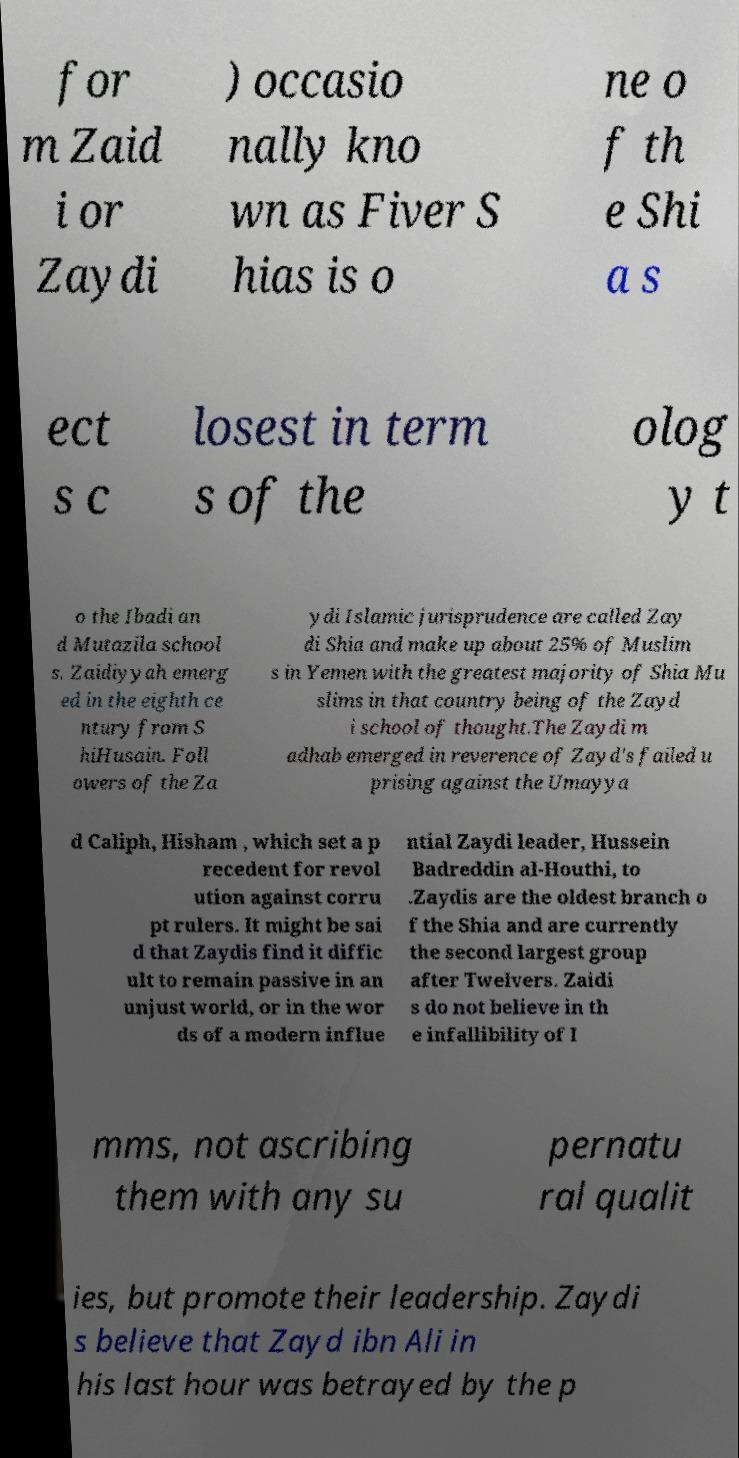Please identify and transcribe the text found in this image. for m Zaid i or Zaydi ) occasio nally kno wn as Fiver S hias is o ne o f th e Shi a s ect s c losest in term s of the olog y t o the Ibadi an d Mutazila school s. Zaidiyyah emerg ed in the eighth ce ntury from S hiHusain. Foll owers of the Za ydi Islamic jurisprudence are called Zay di Shia and make up about 25% of Muslim s in Yemen with the greatest majority of Shia Mu slims in that country being of the Zayd i school of thought.The Zaydi m adhab emerged in reverence of Zayd's failed u prising against the Umayya d Caliph, Hisham , which set a p recedent for revol ution against corru pt rulers. It might be sai d that Zaydis find it diffic ult to remain passive in an unjust world, or in the wor ds of a modern influe ntial Zaydi leader, Hussein Badreddin al-Houthi, to .Zaydis are the oldest branch o f the Shia and are currently the second largest group after Twelvers. Zaidi s do not believe in th e infallibility of I mms, not ascribing them with any su pernatu ral qualit ies, but promote their leadership. Zaydi s believe that Zayd ibn Ali in his last hour was betrayed by the p 